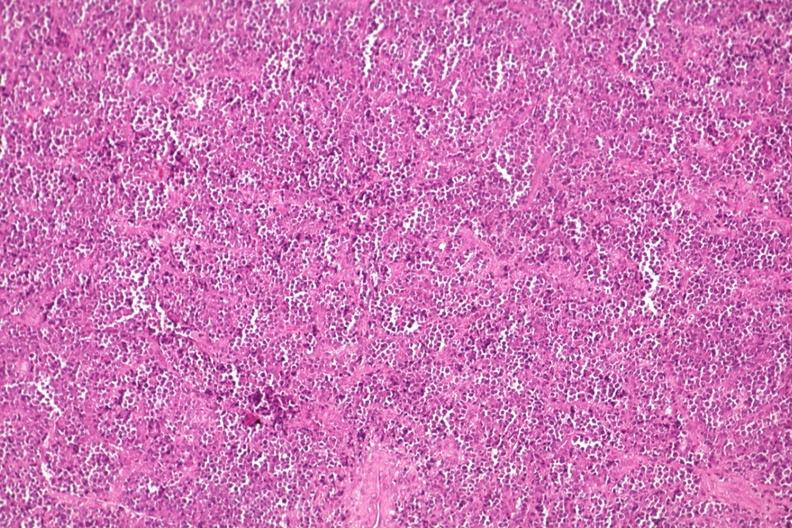what does this image show?
Answer the question using a single word or phrase. Distal femur lesion 